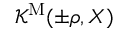<formula> <loc_0><loc_0><loc_500><loc_500>{ \mathcal { K } } ^ { M } ( \pm \rho , X )</formula> 